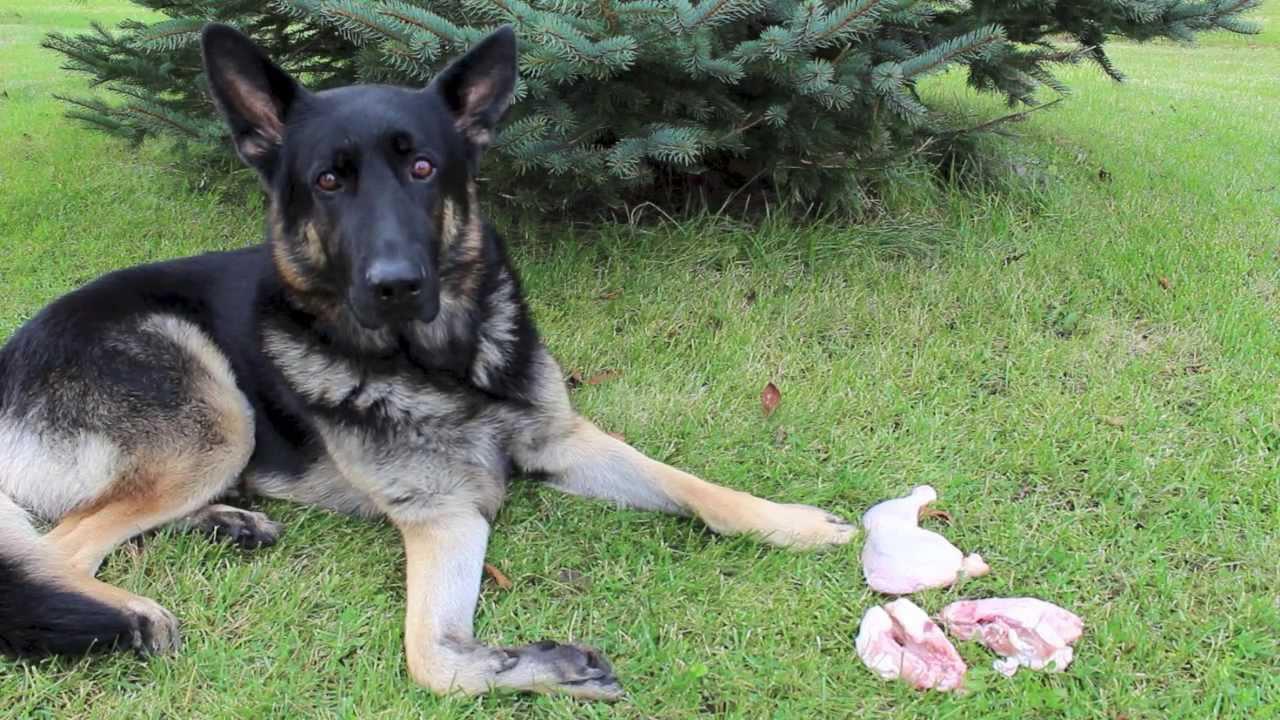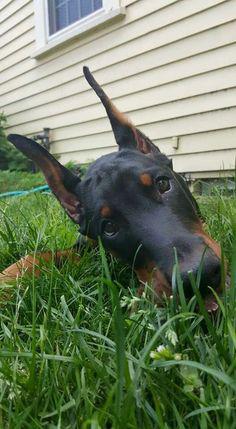The first image is the image on the left, the second image is the image on the right. For the images displayed, is the sentence "Two dogs are laying in grass." factually correct? Answer yes or no. Yes. The first image is the image on the left, the second image is the image on the right. Examine the images to the left and right. Is the description "The right image features one doberman with its front paws forward on the ground and its mouth on a pale object on the grass." accurate? Answer yes or no. No. 